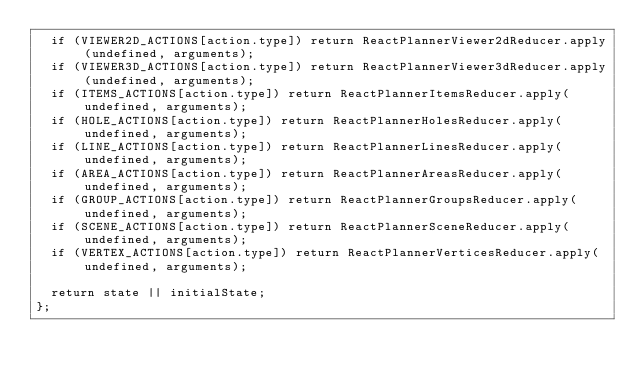<code> <loc_0><loc_0><loc_500><loc_500><_JavaScript_>  if (VIEWER2D_ACTIONS[action.type]) return ReactPlannerViewer2dReducer.apply(undefined, arguments);
  if (VIEWER3D_ACTIONS[action.type]) return ReactPlannerViewer3dReducer.apply(undefined, arguments);
  if (ITEMS_ACTIONS[action.type]) return ReactPlannerItemsReducer.apply(undefined, arguments);
  if (HOLE_ACTIONS[action.type]) return ReactPlannerHolesReducer.apply(undefined, arguments);
  if (LINE_ACTIONS[action.type]) return ReactPlannerLinesReducer.apply(undefined, arguments);
  if (AREA_ACTIONS[action.type]) return ReactPlannerAreasReducer.apply(undefined, arguments);
  if (GROUP_ACTIONS[action.type]) return ReactPlannerGroupsReducer.apply(undefined, arguments);
  if (SCENE_ACTIONS[action.type]) return ReactPlannerSceneReducer.apply(undefined, arguments);
  if (VERTEX_ACTIONS[action.type]) return ReactPlannerVerticesReducer.apply(undefined, arguments);

  return state || initialState;
};</code> 